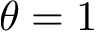<formula> <loc_0><loc_0><loc_500><loc_500>\theta = 1</formula> 